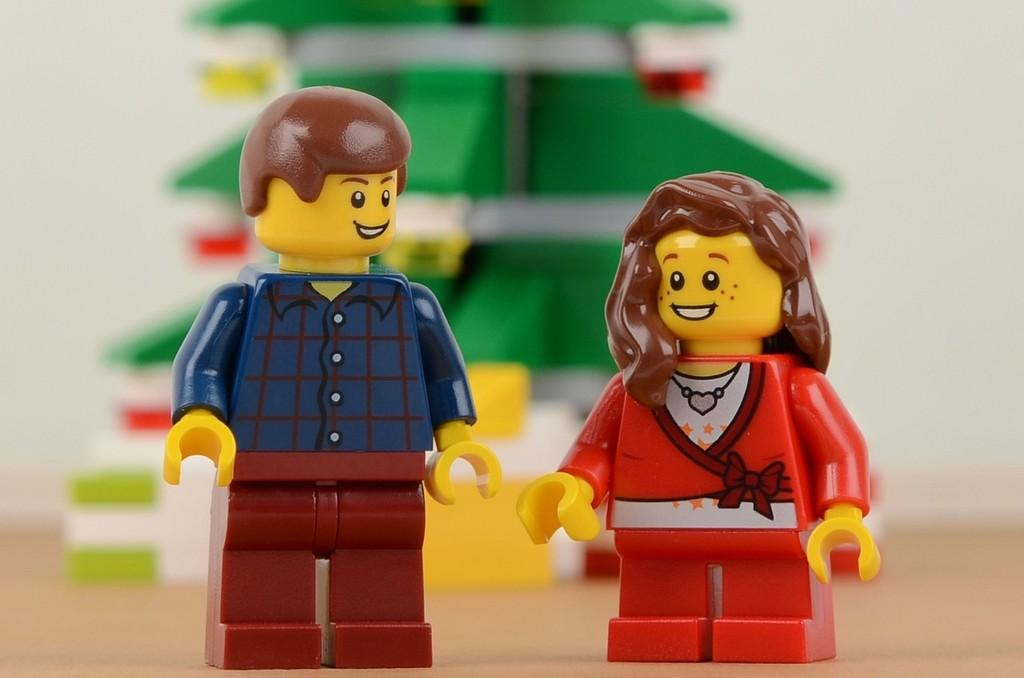How many toys can be seen in the image? There are two toys in the image. Can you describe the background of the image? The background of the image is blurry. What type of health issues are being discussed by the toys in the image? There are no toys discussing health issues in the image, as they are inanimate objects and cannot engage in discussions. 